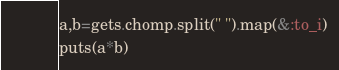<code> <loc_0><loc_0><loc_500><loc_500><_Ruby_>a,b=gets.chomp.split(" ").map(&:to_i)
puts(a*b)
</code> 